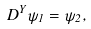<formula> <loc_0><loc_0><loc_500><loc_500>D ^ { Y } \psi _ { 1 } = \psi _ { 2 } ,</formula> 